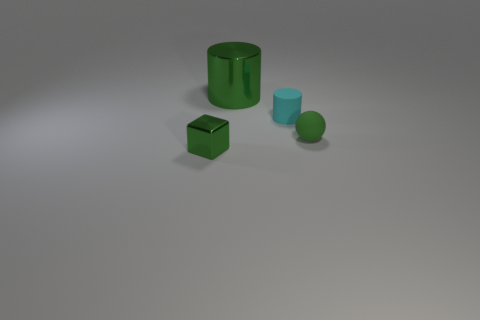Add 1 small green rubber balls. How many objects exist? 5 Subtract all spheres. How many objects are left? 3 Subtract all spheres. Subtract all big metal objects. How many objects are left? 2 Add 2 green shiny things. How many green shiny things are left? 4 Add 2 tiny cyan matte cubes. How many tiny cyan matte cubes exist? 2 Subtract 1 green blocks. How many objects are left? 3 